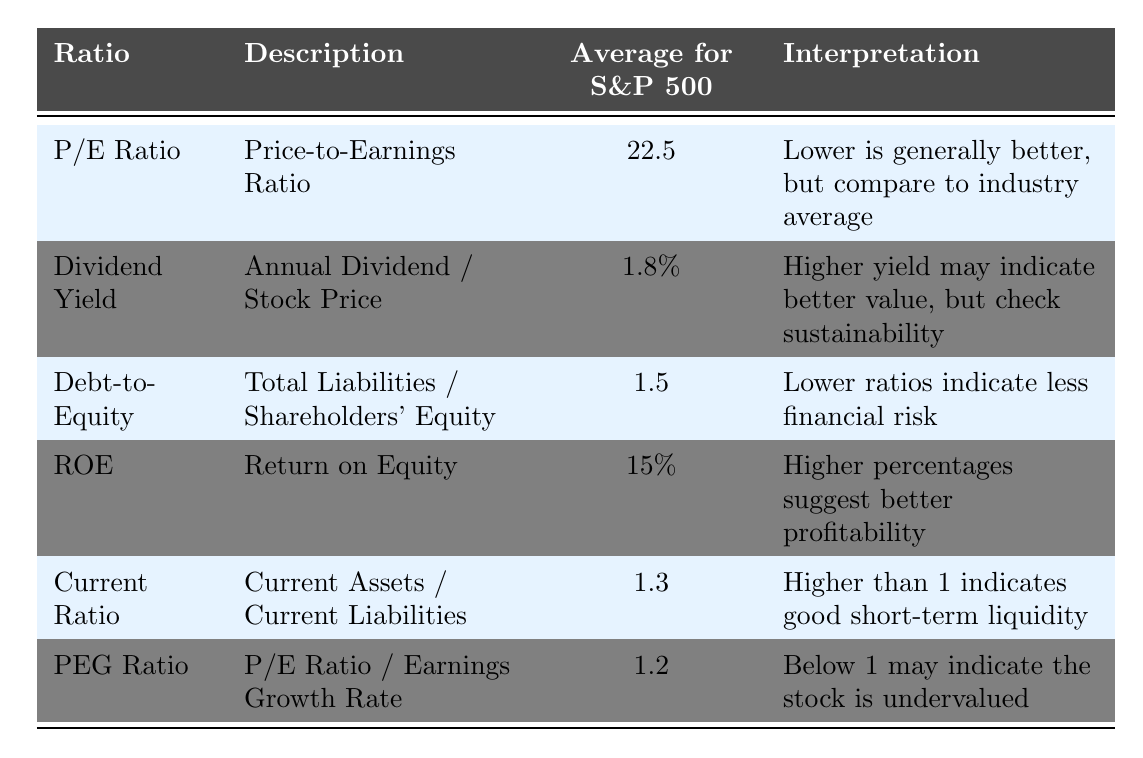What is the average P/E Ratio for the S&P 500? The table shows that the average P/E Ratio listed under "Average for S&P 500" is 22.5.
Answer: 22.5 What does a higher Dividend Yield suggest according to the table? The interpretation column states that a higher dividend yield may indicate better value, but it's crucial to check the sustainability of that yield.
Answer: A higher Dividend Yield suggests better value What is the average Debt-to-Equity ratio for the S&P 500? The average Debt-to-Equity ratio can be found in the table, and it is listed as 1.5.
Answer: 1.5 Is a Current Ratio of 1.3 considered good short-term liquidity? According to the interpretation provided in the table, a Current Ratio higher than 1 indicates good short-term liquidity. Since 1.3 is greater than 1, the answer is yes.
Answer: Yes If the PEG Ratio is 1.2, does it suggest the stock is undervalued? The table states that a PEG Ratio below 1 may indicate the stock is undervalued. Since 1.2 is above 1, it does not suggest undervaluation.
Answer: No What is the difference between the average ROE and the average Dividend Yield? The average ROE is 15%, which can be expressed as 0.15 when using percentage for mathematical operations. The average Dividend Yield is 1.8%, or 0.018. The difference is 0.15 - 0.018 = 0.132, or 13.2%.
Answer: 13.2% What are the implications of a lower Debt-to-Equity ratio? The interpretation in the table states that lower Debt-to-Equity ratios indicate less financial risk. This implies that a company with a lower ratio is viewed as being more stable financially.
Answer: Less financial risk How does the interpretation of the PEG Ratio change if it's below 1 instead of above 1? The table indicates that a PEG Ratio below 1 suggests the stock may be undervalued while a PEG Ratio above 1 does not indicate undervaluation, suggesting different investment implications.
Answer: It indicates undervaluation if below 1 